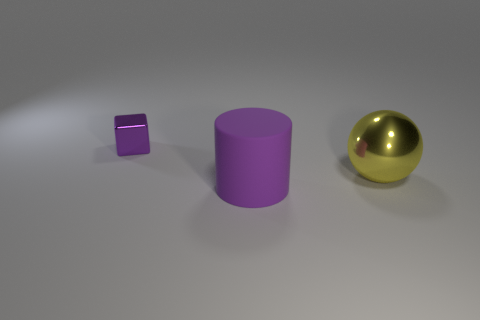Do the big metallic sphere and the shiny block have the same color?
Ensure brevity in your answer.  No. There is a purple object behind the purple object on the right side of the tiny purple object; what is its shape?
Your response must be concise. Cube. There is a tiny purple thing that is the same material as the yellow sphere; what shape is it?
Offer a very short reply. Cube. How many other objects are the same shape as the big purple thing?
Your answer should be very brief. 0. Does the thing behind the yellow sphere have the same size as the big yellow metallic object?
Your answer should be very brief. No. Are there more big spheres that are on the left side of the yellow metal sphere than small purple cylinders?
Provide a short and direct response. No. What number of purple cubes are on the right side of the large object that is left of the yellow shiny thing?
Make the answer very short. 0. Are there fewer yellow things that are to the right of the big yellow ball than cylinders?
Offer a very short reply. Yes. Are there any objects that are on the left side of the metal thing on the right side of the purple object that is right of the shiny block?
Your answer should be very brief. Yes. Are the cube and the big thing on the right side of the cylinder made of the same material?
Provide a succinct answer. Yes. 